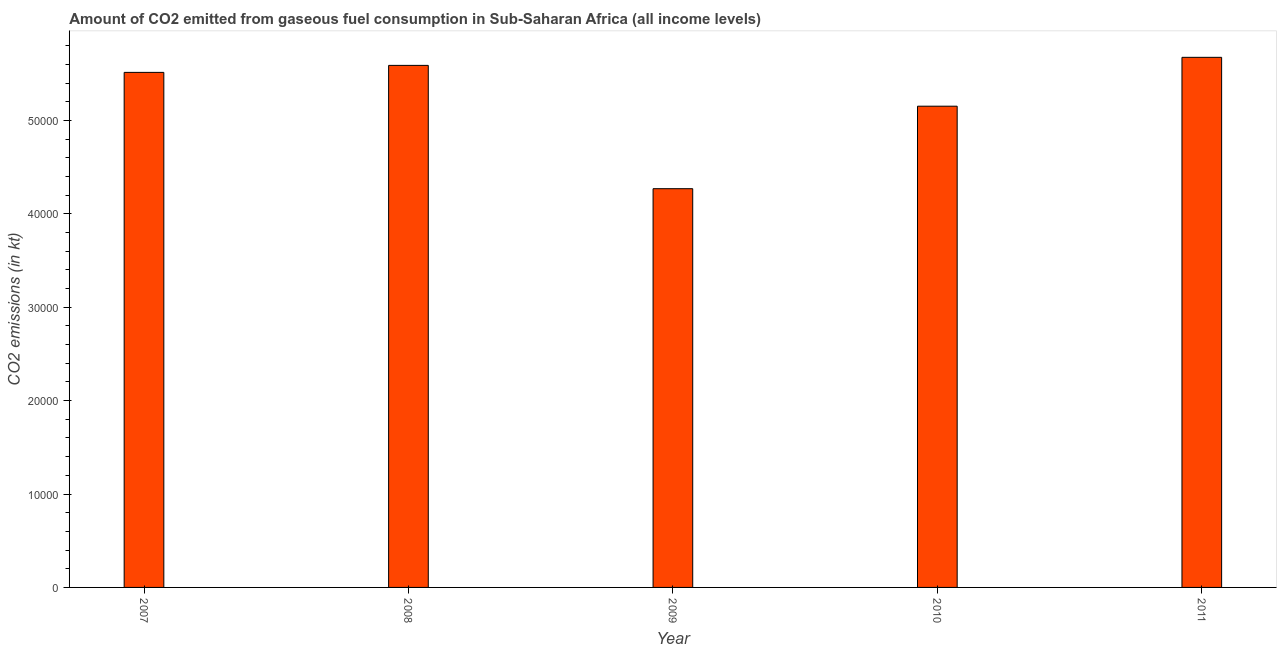What is the title of the graph?
Offer a very short reply. Amount of CO2 emitted from gaseous fuel consumption in Sub-Saharan Africa (all income levels). What is the label or title of the Y-axis?
Your answer should be compact. CO2 emissions (in kt). What is the co2 emissions from gaseous fuel consumption in 2011?
Give a very brief answer. 5.68e+04. Across all years, what is the maximum co2 emissions from gaseous fuel consumption?
Your response must be concise. 5.68e+04. Across all years, what is the minimum co2 emissions from gaseous fuel consumption?
Provide a short and direct response. 4.27e+04. In which year was the co2 emissions from gaseous fuel consumption maximum?
Keep it short and to the point. 2011. What is the sum of the co2 emissions from gaseous fuel consumption?
Ensure brevity in your answer.  2.62e+05. What is the difference between the co2 emissions from gaseous fuel consumption in 2007 and 2008?
Provide a short and direct response. -748.49. What is the average co2 emissions from gaseous fuel consumption per year?
Provide a short and direct response. 5.24e+04. What is the median co2 emissions from gaseous fuel consumption?
Your answer should be very brief. 5.51e+04. In how many years, is the co2 emissions from gaseous fuel consumption greater than 48000 kt?
Your response must be concise. 4. Do a majority of the years between 2011 and 2007 (inclusive) have co2 emissions from gaseous fuel consumption greater than 34000 kt?
Your answer should be very brief. Yes. What is the ratio of the co2 emissions from gaseous fuel consumption in 2008 to that in 2010?
Keep it short and to the point. 1.08. Is the difference between the co2 emissions from gaseous fuel consumption in 2008 and 2010 greater than the difference between any two years?
Ensure brevity in your answer.  No. What is the difference between the highest and the second highest co2 emissions from gaseous fuel consumption?
Ensure brevity in your answer.  862.9. Is the sum of the co2 emissions from gaseous fuel consumption in 2007 and 2009 greater than the maximum co2 emissions from gaseous fuel consumption across all years?
Make the answer very short. Yes. What is the difference between the highest and the lowest co2 emissions from gaseous fuel consumption?
Give a very brief answer. 1.41e+04. In how many years, is the co2 emissions from gaseous fuel consumption greater than the average co2 emissions from gaseous fuel consumption taken over all years?
Your response must be concise. 3. Are all the bars in the graph horizontal?
Provide a short and direct response. No. How many years are there in the graph?
Offer a very short reply. 5. Are the values on the major ticks of Y-axis written in scientific E-notation?
Keep it short and to the point. No. What is the CO2 emissions (in kt) in 2007?
Your answer should be compact. 5.51e+04. What is the CO2 emissions (in kt) of 2008?
Give a very brief answer. 5.59e+04. What is the CO2 emissions (in kt) in 2009?
Provide a short and direct response. 4.27e+04. What is the CO2 emissions (in kt) of 2010?
Provide a short and direct response. 5.15e+04. What is the CO2 emissions (in kt) of 2011?
Offer a terse response. 5.68e+04. What is the difference between the CO2 emissions (in kt) in 2007 and 2008?
Provide a succinct answer. -748.49. What is the difference between the CO2 emissions (in kt) in 2007 and 2009?
Provide a short and direct response. 1.25e+04. What is the difference between the CO2 emissions (in kt) in 2007 and 2010?
Offer a very short reply. 3620.9. What is the difference between the CO2 emissions (in kt) in 2007 and 2011?
Offer a terse response. -1611.38. What is the difference between the CO2 emissions (in kt) in 2008 and 2009?
Provide a short and direct response. 1.32e+04. What is the difference between the CO2 emissions (in kt) in 2008 and 2010?
Keep it short and to the point. 4369.39. What is the difference between the CO2 emissions (in kt) in 2008 and 2011?
Offer a terse response. -862.9. What is the difference between the CO2 emissions (in kt) in 2009 and 2010?
Provide a succinct answer. -8833.06. What is the difference between the CO2 emissions (in kt) in 2009 and 2011?
Offer a very short reply. -1.41e+04. What is the difference between the CO2 emissions (in kt) in 2010 and 2011?
Provide a succinct answer. -5232.29. What is the ratio of the CO2 emissions (in kt) in 2007 to that in 2009?
Give a very brief answer. 1.29. What is the ratio of the CO2 emissions (in kt) in 2007 to that in 2010?
Ensure brevity in your answer.  1.07. What is the ratio of the CO2 emissions (in kt) in 2008 to that in 2009?
Make the answer very short. 1.31. What is the ratio of the CO2 emissions (in kt) in 2008 to that in 2010?
Make the answer very short. 1.08. What is the ratio of the CO2 emissions (in kt) in 2009 to that in 2010?
Your answer should be very brief. 0.83. What is the ratio of the CO2 emissions (in kt) in 2009 to that in 2011?
Provide a succinct answer. 0.75. What is the ratio of the CO2 emissions (in kt) in 2010 to that in 2011?
Offer a terse response. 0.91. 